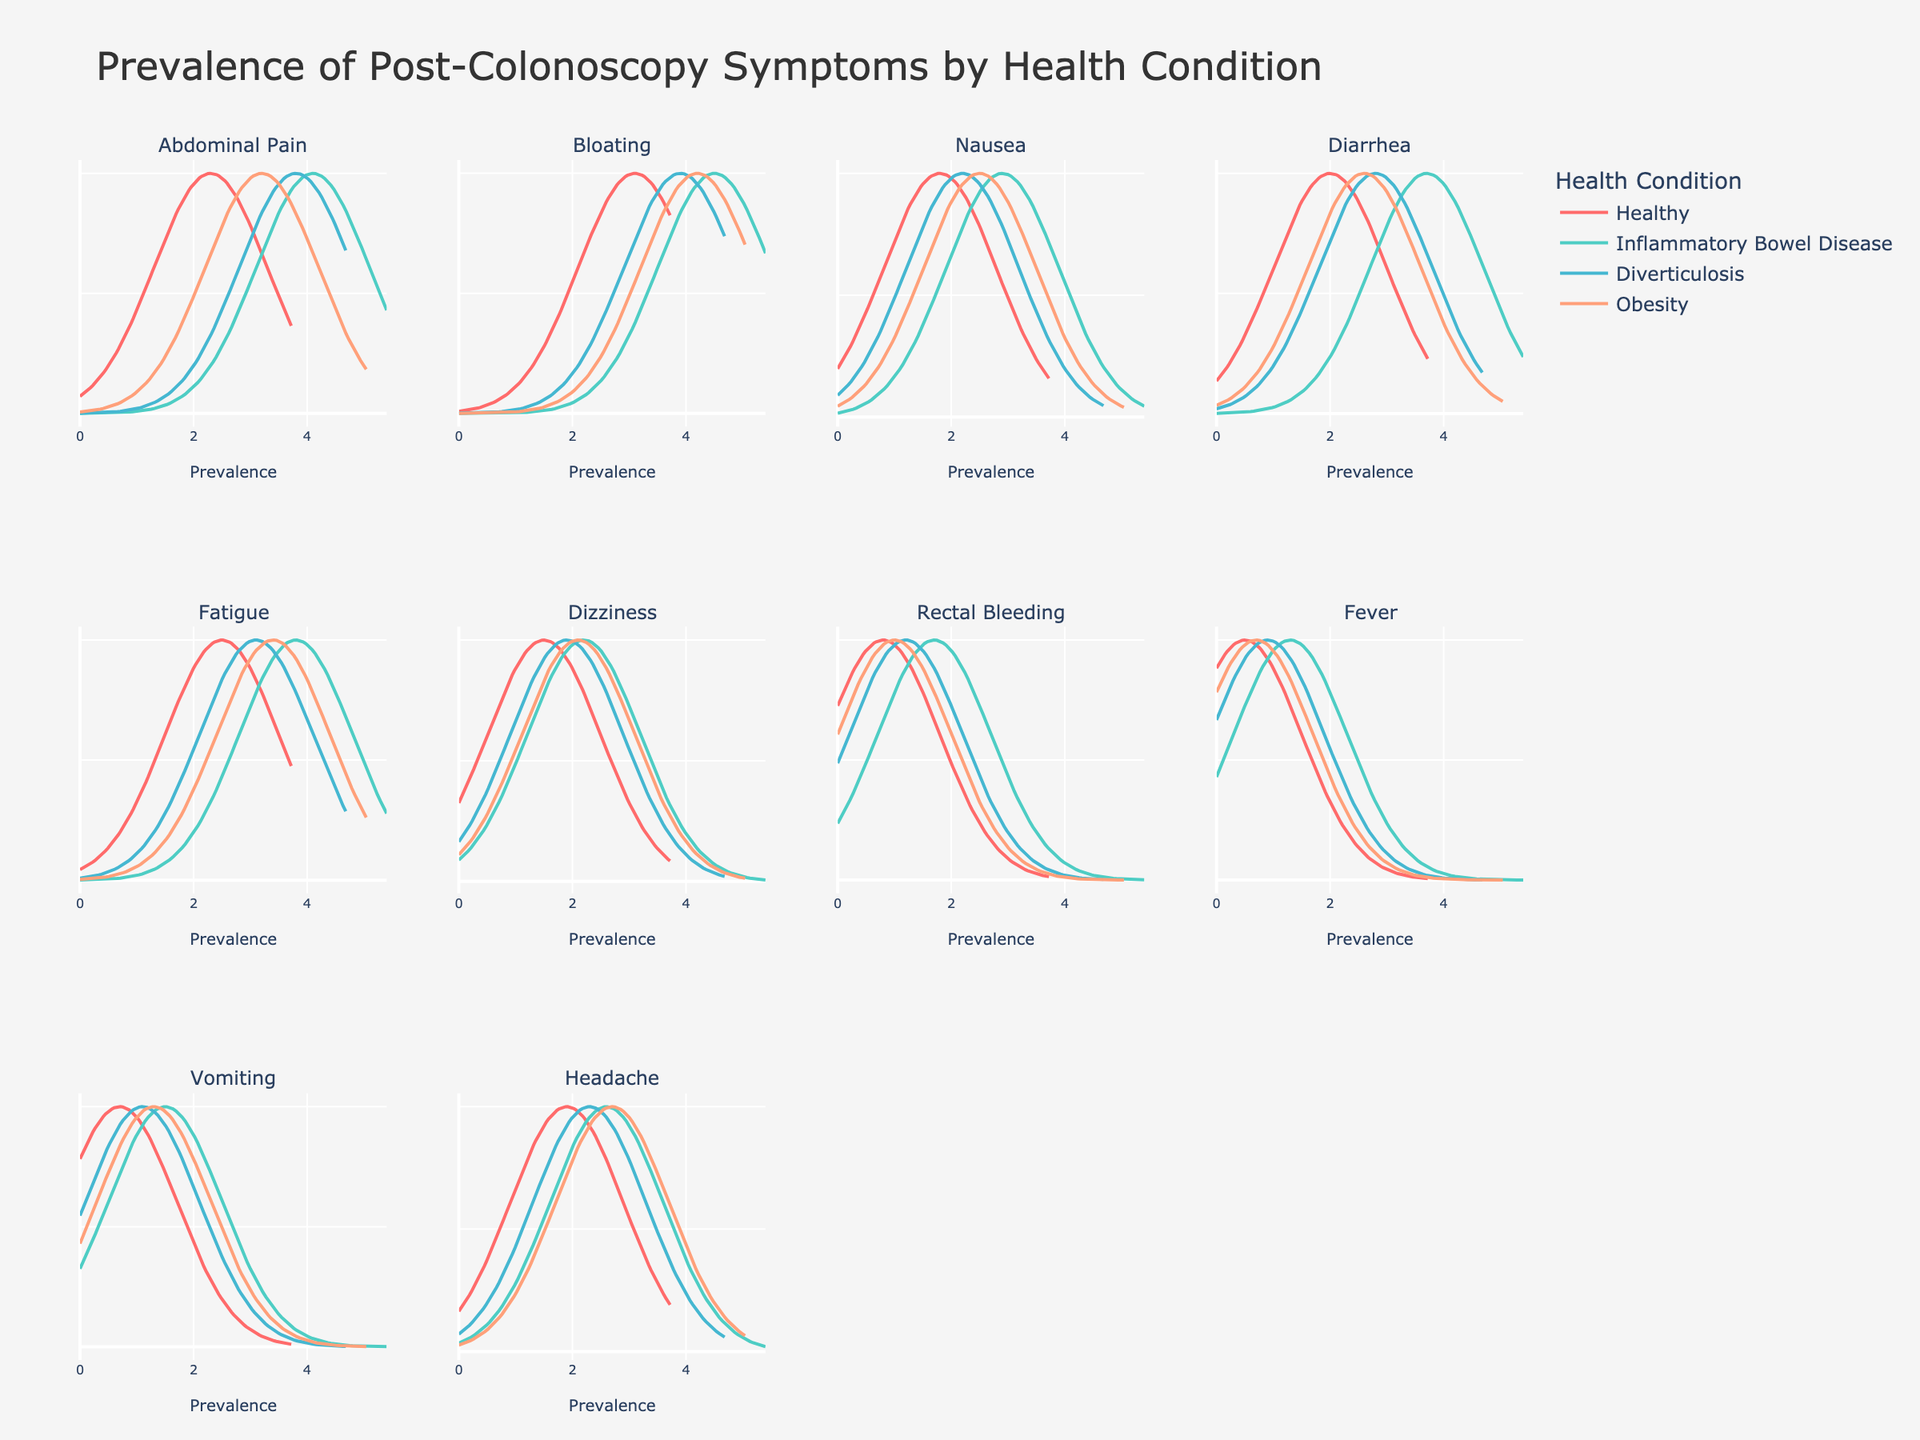What is the title of the figure? The title of the figure is located at the top and clearly states the purpose of the visualization.
Answer: Prevalence of Post-Colonoscopy Symptoms by Health Condition Which health condition shows the highest prevalence for 'Abdominal Pain'? The subplot for 'Abdominal Pain' shows four density plots with different peaks. The peak for 'Inflammatory Bowel Disease' is the highest.
Answer: Inflammatory Bowel Disease How many subplots are there in the entire figure? Each subplot corresponds to a different symptom, and there are 12 subplots arranged in a 3 by 4 grid.
Answer: 12 What symptom has the lowest prevalence in healthy individuals? By observing the peaks of the density plots for each symptom in the 'Healthy' condition, 'Fever' has the lowest peak.
Answer: Fever Which symptom has a notably higher prevalence in individuals with Obesity compared to those who are Healthy? By comparing the peaks of the density plots for each symptom between 'Obesity' and 'Healthy,' 'Bloating' shows a notably higher peak for 'Obesity.'
Answer: Bloating For which symptom do individuals with Diverticulosis have the same prevalence as those with Obesity? Comparing the peaks for each symptom in 'Diverticulosis' and 'Obesity,' the prevalence of 'Dizziness' is approximately the same for both conditions.
Answer: Dizziness Which condition shows the lowest prevalence for 'Rectal Bleeding'? By observing the peaks of the density plots for 'Rectal Bleeding,' 'Healthy' shows the lowest peak.
Answer: Healthy How does the prevalence of 'Fatigue' compare between healthy individuals and those with Inflammatory Bowel Disease? The density plots for 'Fatigue' show that the prevalence is higher for 'Inflammatory Bowel Disease' compared to 'Healthy.'
Answer: Higher for Inflammatory Bowel Disease Which symptom has the highest overall prevalence across all health conditions? By observing the peaks across all subplots, 'Bloating' tends to have higher peaks compared to other symptoms.
Answer: Bloating Is there any symptom that has the same prevalence across all health conditions? By examining the density plots across all subplots, no symptom appears to have identical prevalence across all conditions.
Answer: No 